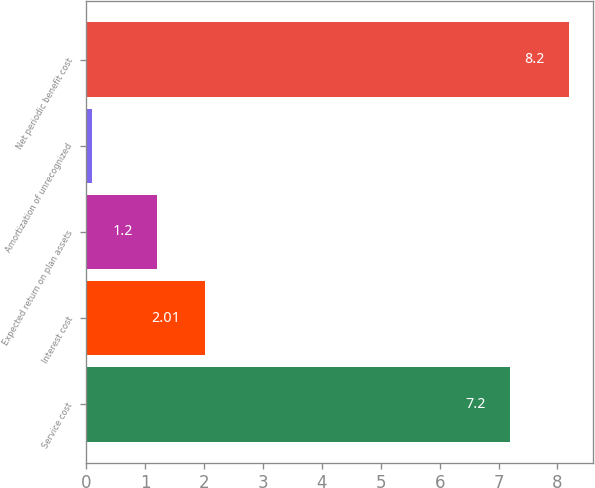Convert chart. <chart><loc_0><loc_0><loc_500><loc_500><bar_chart><fcel>Service cost<fcel>Interest cost<fcel>Expected return on plan assets<fcel>Amortization of unrecognized<fcel>Net periodic benefit cost<nl><fcel>7.2<fcel>2.01<fcel>1.2<fcel>0.1<fcel>8.2<nl></chart> 